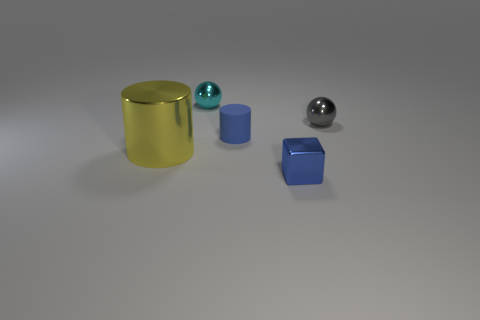There is a sphere that is to the left of the small blue cylinder; are there any cyan metal things that are in front of it?
Offer a very short reply. No. Does the cylinder to the left of the small cyan sphere have the same material as the tiny block?
Provide a short and direct response. Yes. What number of things are both left of the blue cube and on the right side of the big yellow shiny object?
Provide a short and direct response. 2. What number of small spheres have the same material as the small cube?
Your answer should be compact. 2. There is a cylinder that is the same material as the small block; what is its color?
Make the answer very short. Yellow. Are there fewer tiny gray metallic things than big blue cylinders?
Make the answer very short. No. The sphere that is on the left side of the shiny ball to the right of the tiny metal object that is in front of the tiny gray metal sphere is made of what material?
Provide a succinct answer. Metal. What material is the blue cylinder?
Ensure brevity in your answer.  Rubber. There is a tiny shiny sphere right of the small blue metal cube; is it the same color as the tiny sphere left of the tiny cube?
Give a very brief answer. No. Is the number of blue cubes greater than the number of green balls?
Ensure brevity in your answer.  Yes. 